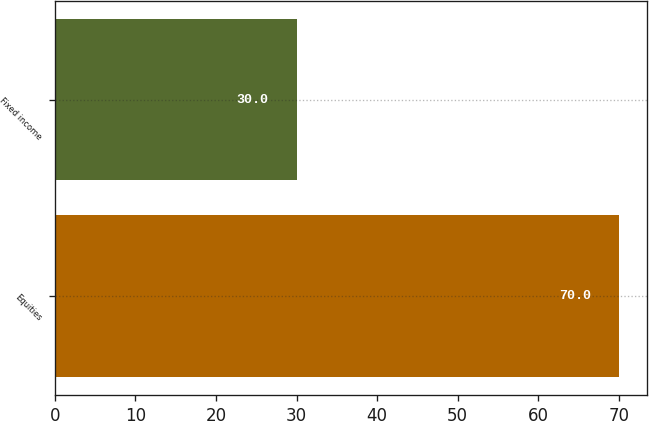Convert chart. <chart><loc_0><loc_0><loc_500><loc_500><bar_chart><fcel>Equities<fcel>Fixed income<nl><fcel>70<fcel>30<nl></chart> 